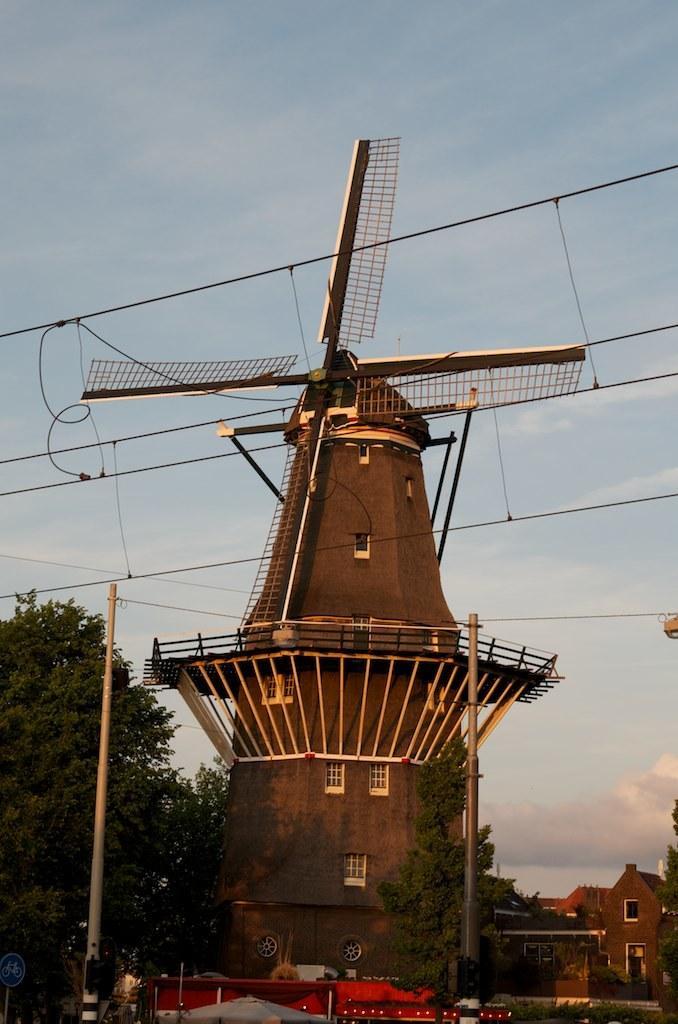In one or two sentences, can you explain what this image depicts? In this picture , this is Windmill and this are some home. 